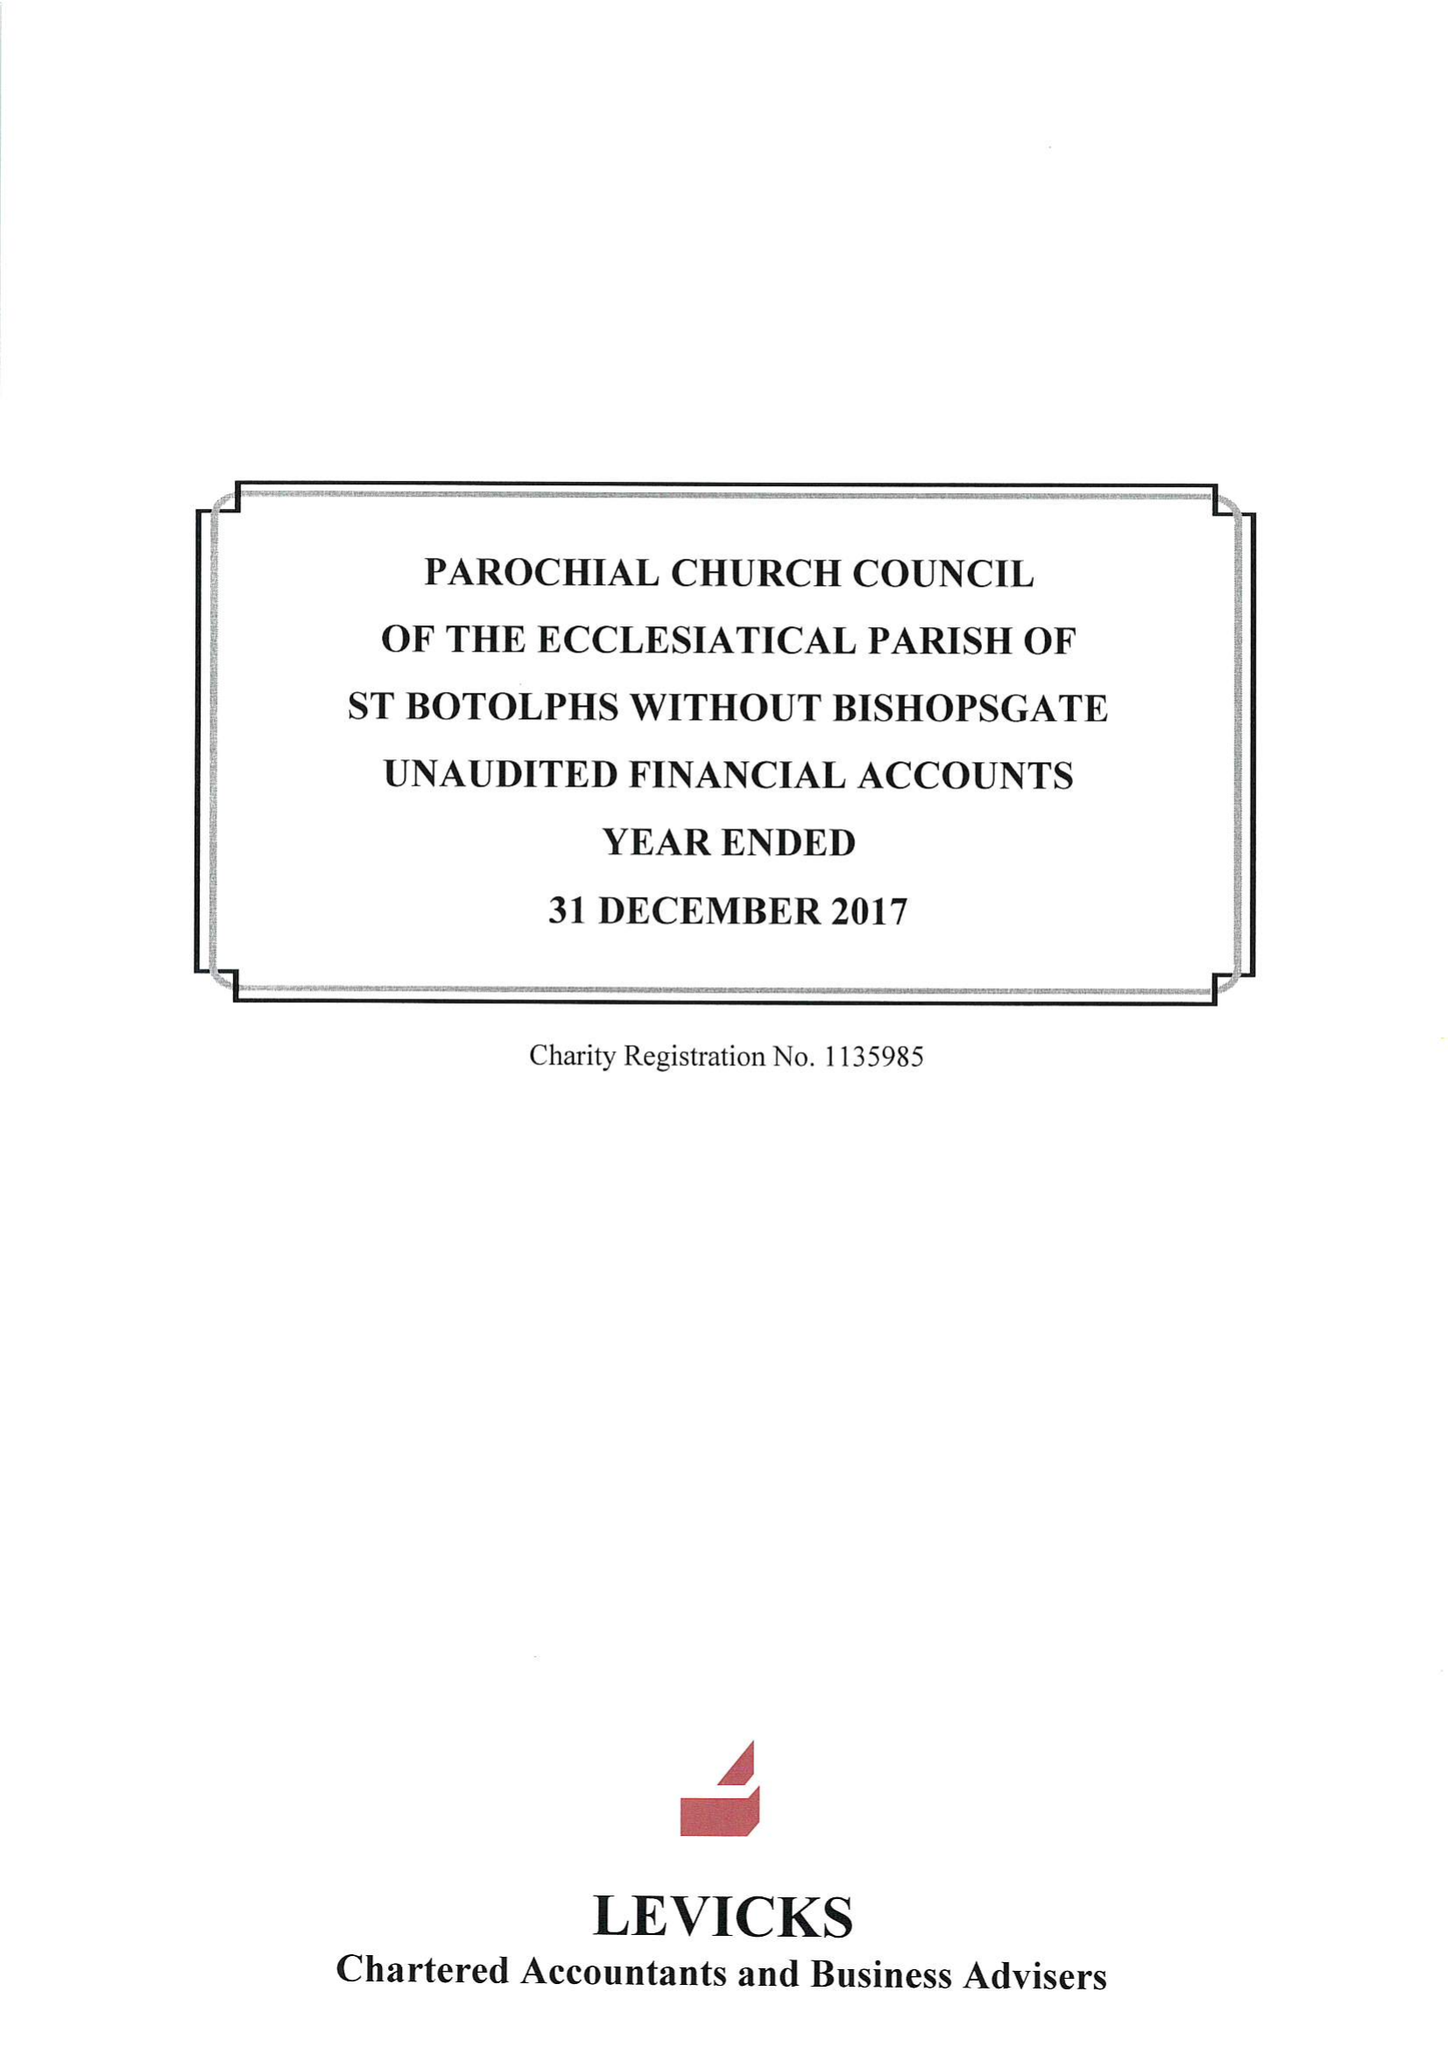What is the value for the address__post_town?
Answer the question using a single word or phrase. LONDON 